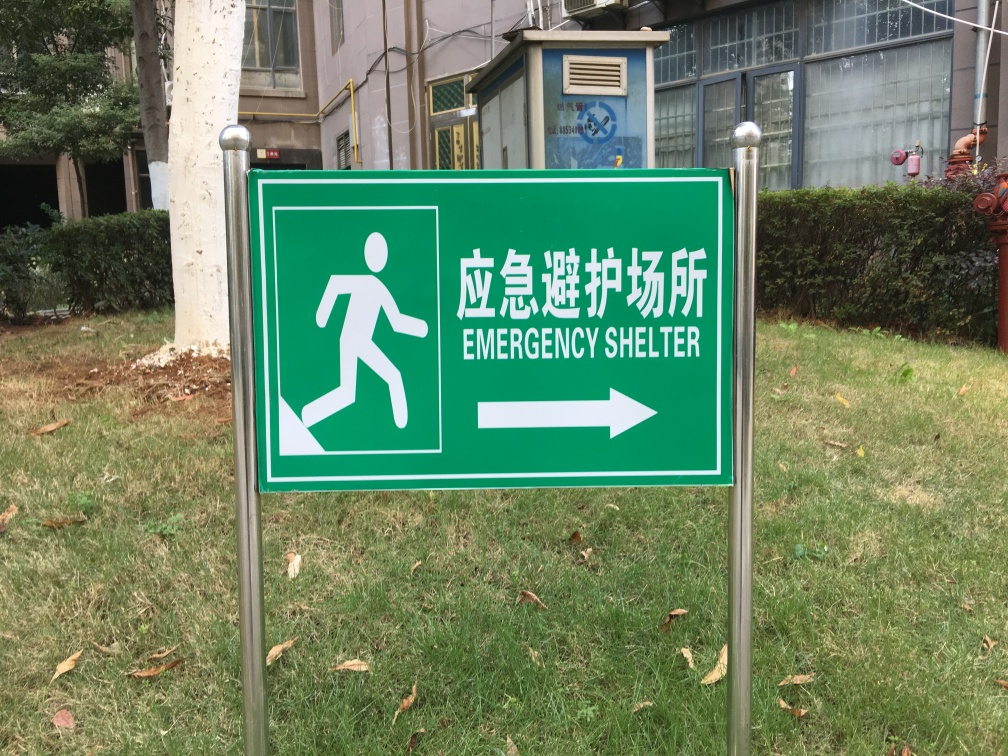How important is signage like this in terms of public safety? Signage like this is crucial for public safety as it provides clear and immediate guidance in times of emergency. It's designed to be easily understood at a glance, which is vital when quick reactions are necessary. Effective signage can significantly impact the efficiency of evacuation and the protection of individuals in high-risk situations. 